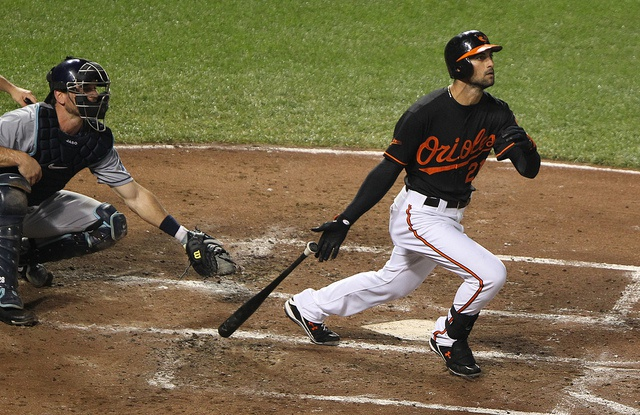Describe the objects in this image and their specific colors. I can see people in olive, black, lavender, darkgray, and gray tones, people in olive, black, gray, and darkgray tones, baseball glove in olive, black, gray, and darkgray tones, baseball bat in olive, black, gray, and darkgray tones, and people in olive, tan, and gray tones in this image. 